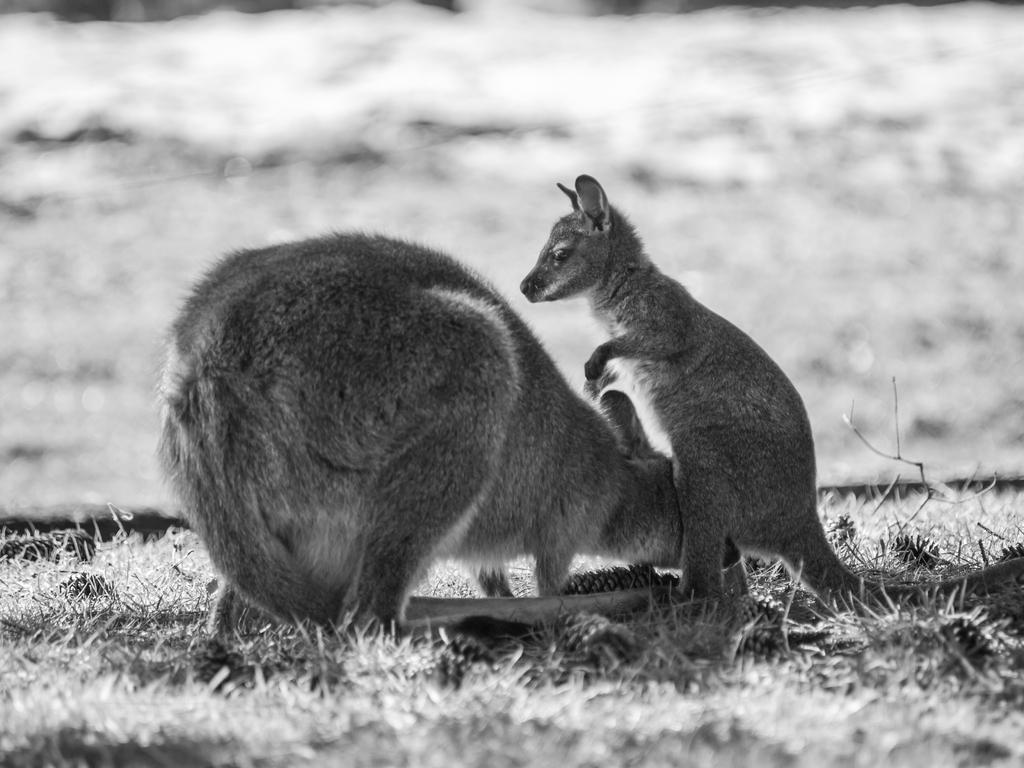What animals are present in the image? There are two kangaroos in the image. How are the kangaroos positioned in relation to each other? The kangaroos are beside each other in the image. What is the color scheme of the image? The image is black and white. What type of vegetation can be seen on the ground in the image? There is grass on the ground in the image. What type of marble is visible in the image? There is no marble present in the image; it features two kangaroos beside each other in a black and white setting with grass on the ground. 